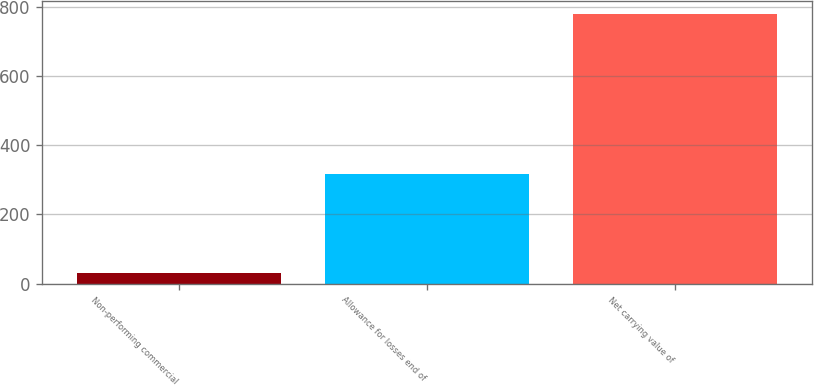Convert chart to OTSL. <chart><loc_0><loc_0><loc_500><loc_500><bar_chart><fcel>Non-performing commercial<fcel>Allowance for losses end of<fcel>Net carrying value of<nl><fcel>30<fcel>316<fcel>778<nl></chart> 